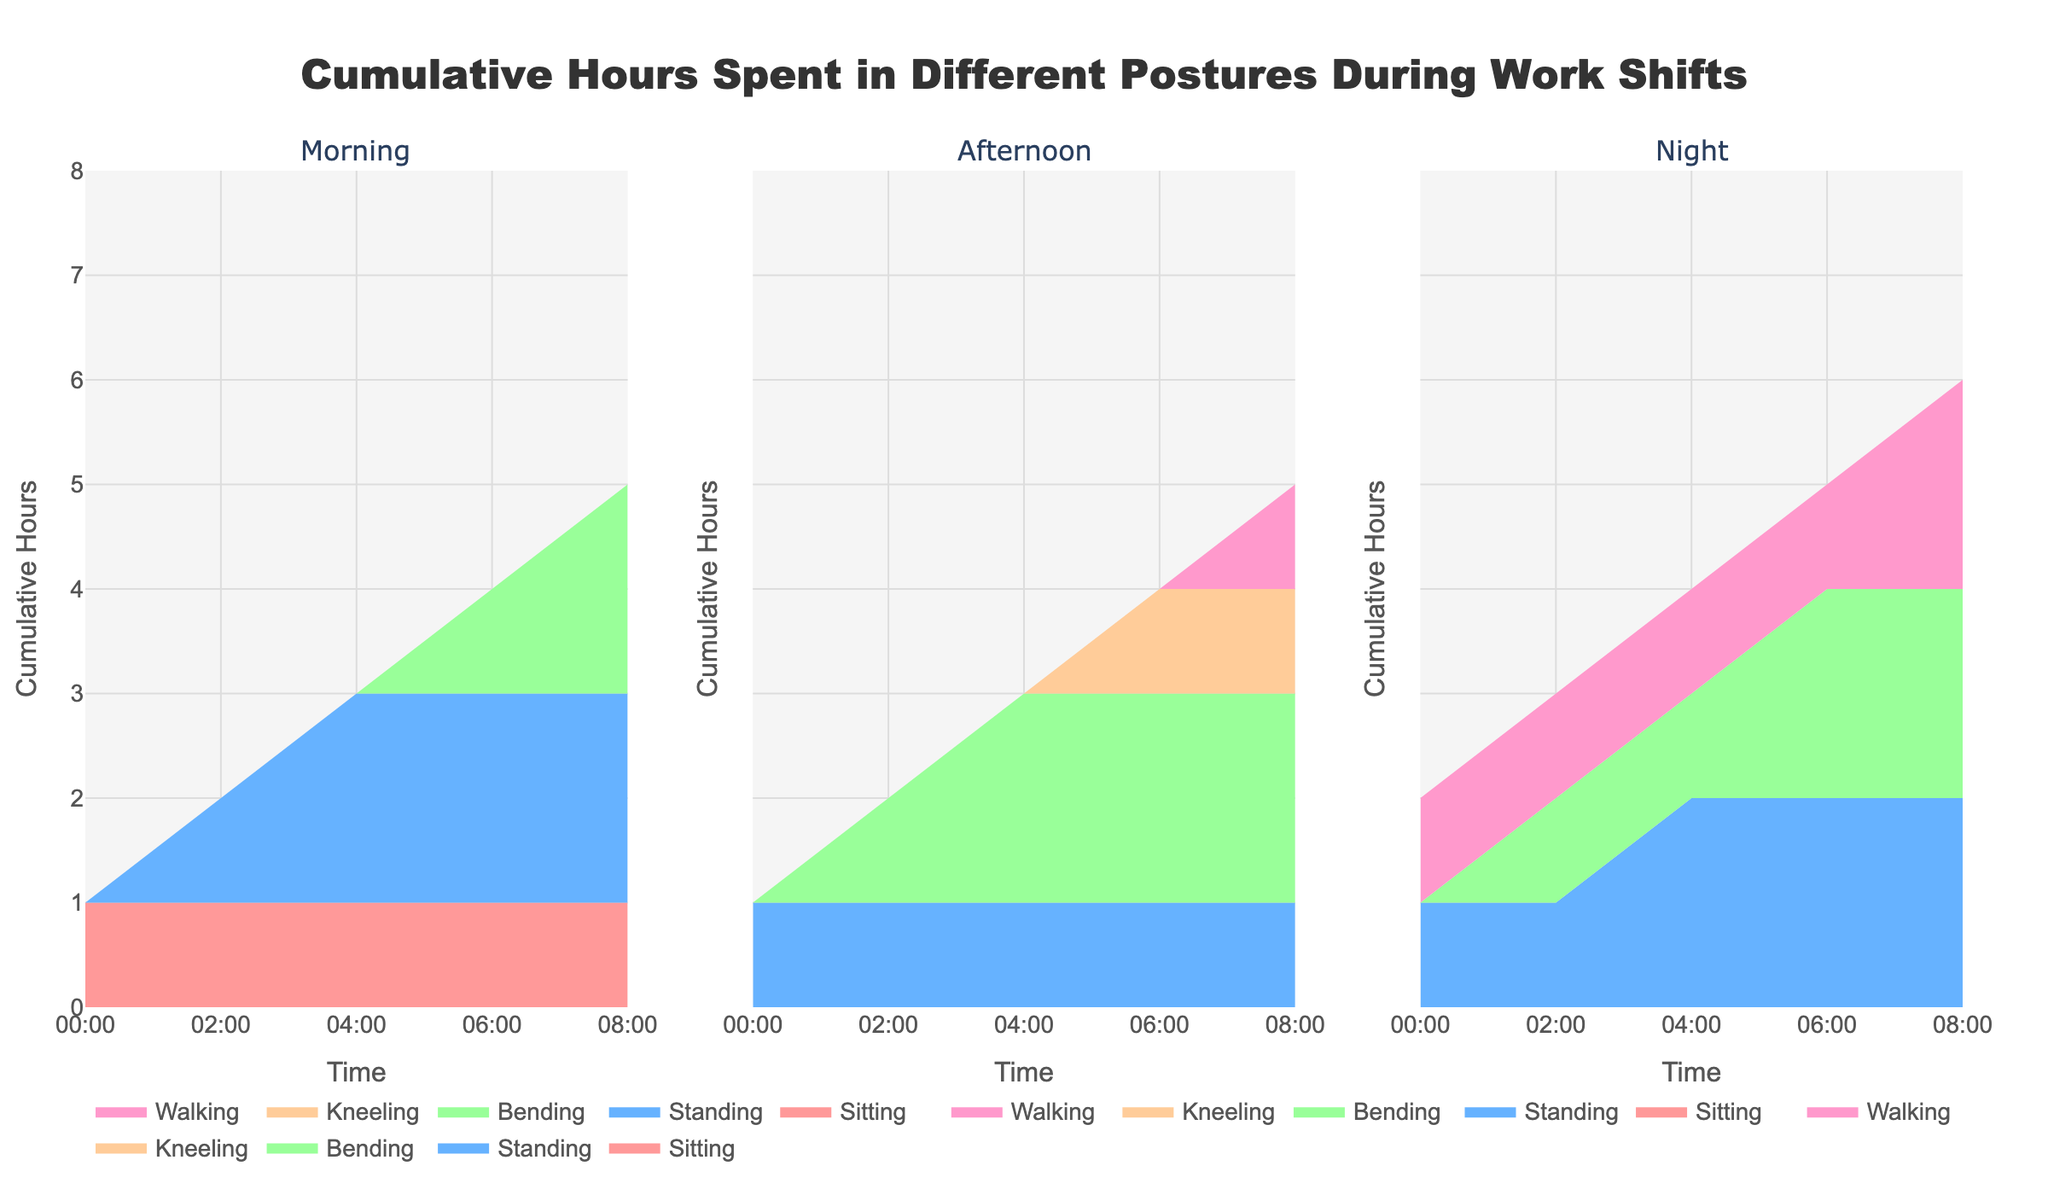What is the title of the chart? The title is usually found at the top of the chart and is a brief description of what the chart represents.
Answer: Cumulative Hours Spent in Different Postures During Work Shifts How many shifts are displayed in the chart? By observing the subplots' titles, we can count the different shifts shown.
Answer: Three Which posture is represented by the color pink in the chart? Each posture is assigned a different color to distinguish them. By identifying the colors in the legend or plot, we can determine which posture corresponds to pink.
Answer: Sitting What is the cumulative number of hours spent kneeling by the end of the night shift? To find this, we look at the last data point for the night shift subplot and check the value corresponding to Kneeling.
Answer: 0 During which shift is the cumulative number of hours spent standing highest at the end of the shift? We compare the cumulative hours spent standing at the end of each shift by checking the last data point for the Standing posture.
Answer: Night Which posture shows the largest increase in cumulative hours during the afternoon shift? By observing the area plot in the afternoon shift subplot, we determine which posture's area grows the most from start to end.
Answer: Sitting How do the cumulative hours spent walking compare between the morning and afternoon shifts at the 06:00 time mark? We look at the cumulative hours for walking at 06:00 in both the morning and afternoon shift subplots.
Answer: The same What is the total cumulative number of hours spent standing throughout all shifts? We add up the cumulative hours spent standing from the final data point of each shift. Morning has 2, Afternoon has 1, and Night has 2.
Answer: 5 Which posture has the least cumulative hours at any point during the morning shift? We observe the areas under the curves in the morning shift subplot to find the smallest area at any given time point.
Answer: Bending In which time frame during the night shift does the cumulative number of hours spent bending increase? By looking at the night shift subplot, we identify when there are increases in the cumulative area for bending.
Answer: Between 00:00 and 04:00 